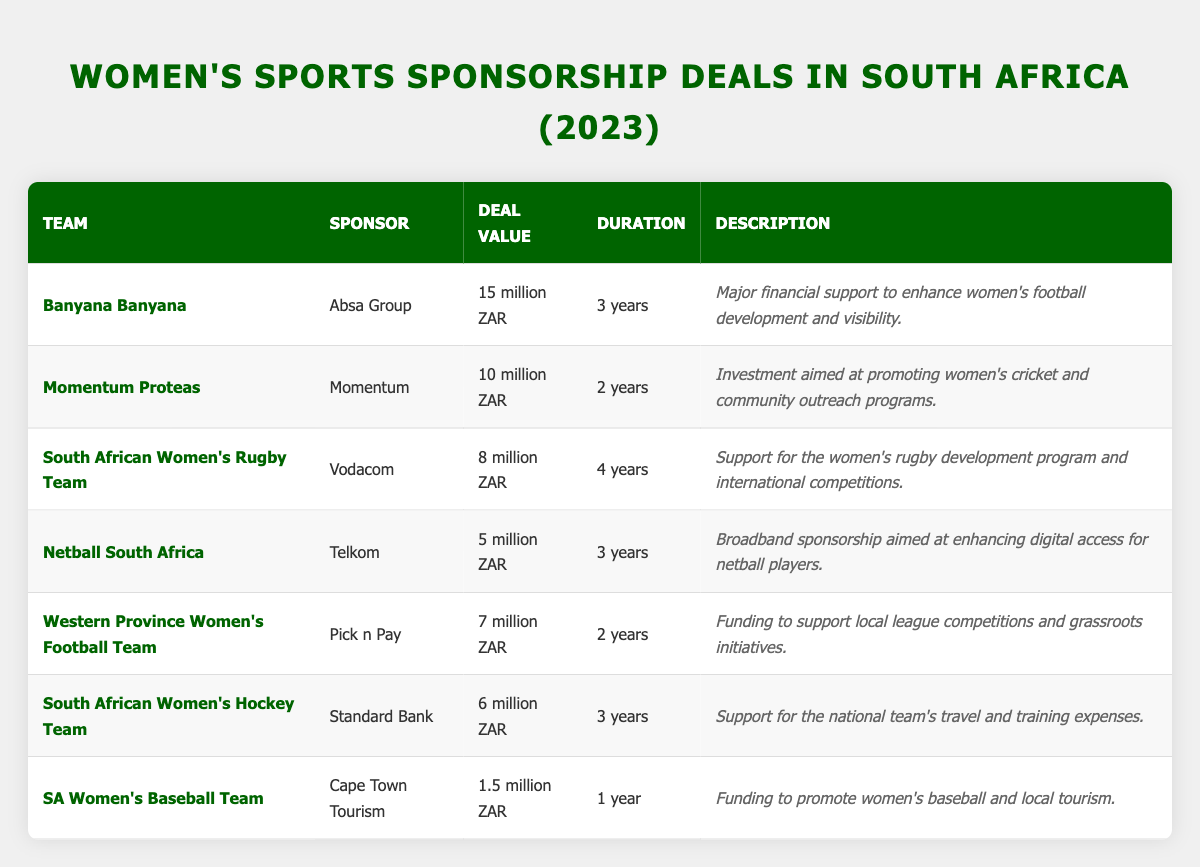What is the total value of sponsorship deals for women's sports teams in South Africa? To find the total value, sum up all the deal values: 15 million + 10 million + 8 million + 5 million + 7 million + 6 million + 1.5 million = 52.5 million ZAR
Answer: 52.5 million ZAR Which team received the highest sponsorship deal? Looking at the table, Banyana Banyana has the highest deal value at 15 million ZAR, compared to other teams listed.
Answer: Banyana Banyana How long is the sponsorship duration for the South African Women's Rugby Team? The table states that the South African Women's Rugby Team's sponsorship deal has a duration of 4 years.
Answer: 4 years What is the average deal value of all the sponsorships? First, sum the deal values: 15 + 10 + 8 + 5 + 7 + 6 + 1.5 = 52.5 million ZAR. There are 7 deals, so divide the total by 7: 52.5 million / 7 ≈ 7.5 million ZAR.
Answer: Approximately 7.5 million ZAR Did any team sign a sponsorship deal worth less than 5 million ZAR? The table shows that the SA Women's Baseball Team was sponsored for 1.5 million ZAR, which is below 5 million ZAR.
Answer: Yes Which sponsor is associated with the Momentum Proteas? The table indicates that the Momentum Proteas were sponsored by Momentum.
Answer: Momentum What is the total duration of sponsorships for teams sponsored by the "Pick n Pay" and "Standard Bank"? Pick n Pay has a contract for 2 years and Standard Bank for 3 years. Adding them together gives 2 + 3 = 5 years.
Answer: 5 years Is it true that all sponsors are local South African companies? The table lists sponsors like Absa Group, Momentum, Vodacom, Telkom, Pick n Pay, Standard Bank, and Cape Town Tourism. All of these are South African companies.
Answer: Yes What proportion of the total deal value does the sponsorship deal for the SA Women's Baseball Team represent? The SA Women's Baseball Team has a deal value of 1.5 million ZAR. The total deal value is 52.5 million ZAR. Thus, the proportion is 1.5 million / 52.5 million ≈ 0.0286 or 2.86% when expressed as a percentage.
Answer: Approximately 2.86% Which team has the second highest sponsorship value, and what is that value? The Banyana Banyana has the highest value (15 million), and the Momentum Proteas is next at 10 million ZAR.
Answer: Momentum Proteas, 10 million ZAR 